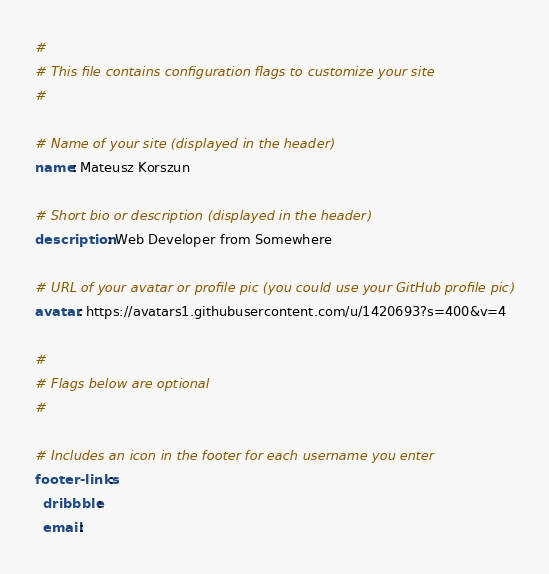Convert code to text. <code><loc_0><loc_0><loc_500><loc_500><_YAML_>#
# This file contains configuration flags to customize your site
#

# Name of your site (displayed in the header)
name: Mateusz Korszun

# Short bio or description (displayed in the header)
description: Web Developer from Somewhere

# URL of your avatar or profile pic (you could use your GitHub profile pic)
avatar: https://avatars1.githubusercontent.com/u/1420693?s=400&v=4

#
# Flags below are optional
#

# Includes an icon in the footer for each username you enter
footer-links:
  dribbble:
  email:</code> 